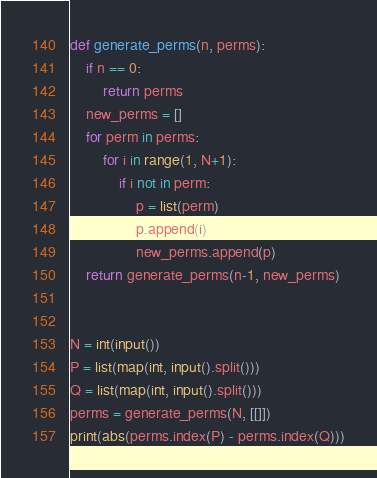<code> <loc_0><loc_0><loc_500><loc_500><_Python_>def generate_perms(n, perms):
    if n == 0:
        return perms
    new_perms = []
    for perm in perms:
        for i in range(1, N+1):
            if i not in perm:
                p = list(perm)
                p.append(i)
                new_perms.append(p)
    return generate_perms(n-1, new_perms)


N = int(input())
P = list(map(int, input().split()))
Q = list(map(int, input().split()))
perms = generate_perms(N, [[]])
print(abs(perms.index(P) - perms.index(Q)))
</code> 